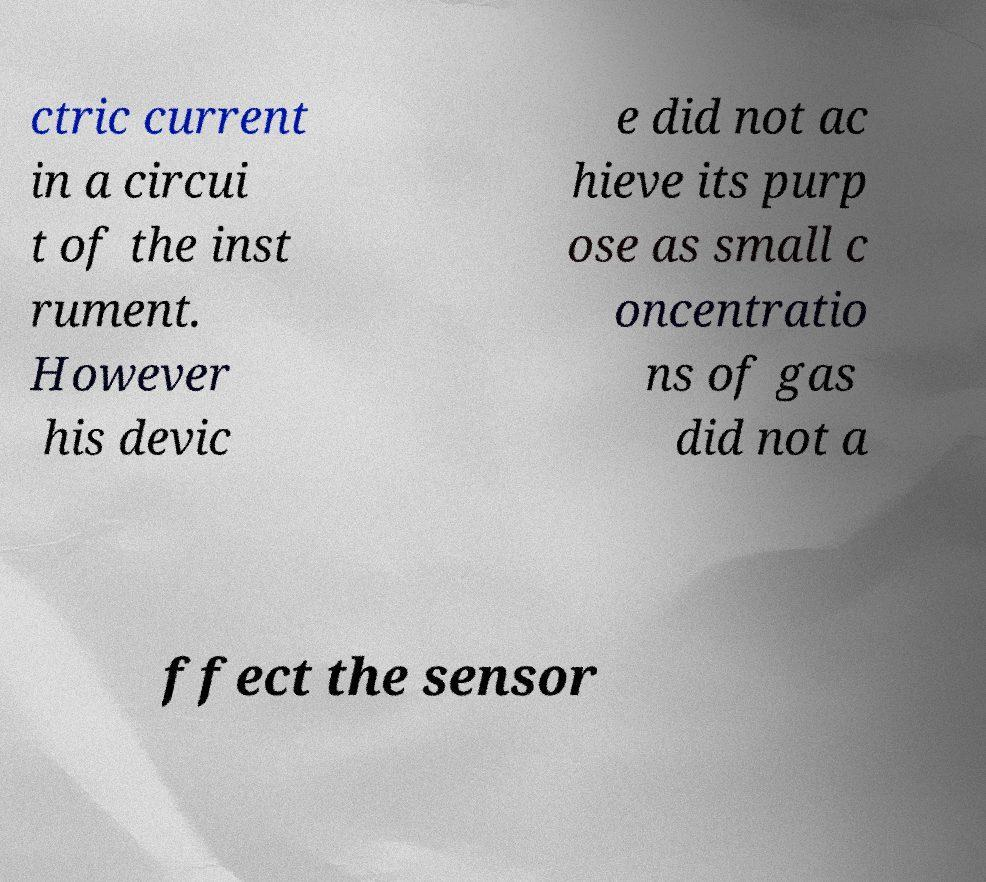Please identify and transcribe the text found in this image. ctric current in a circui t of the inst rument. However his devic e did not ac hieve its purp ose as small c oncentratio ns of gas did not a ffect the sensor 